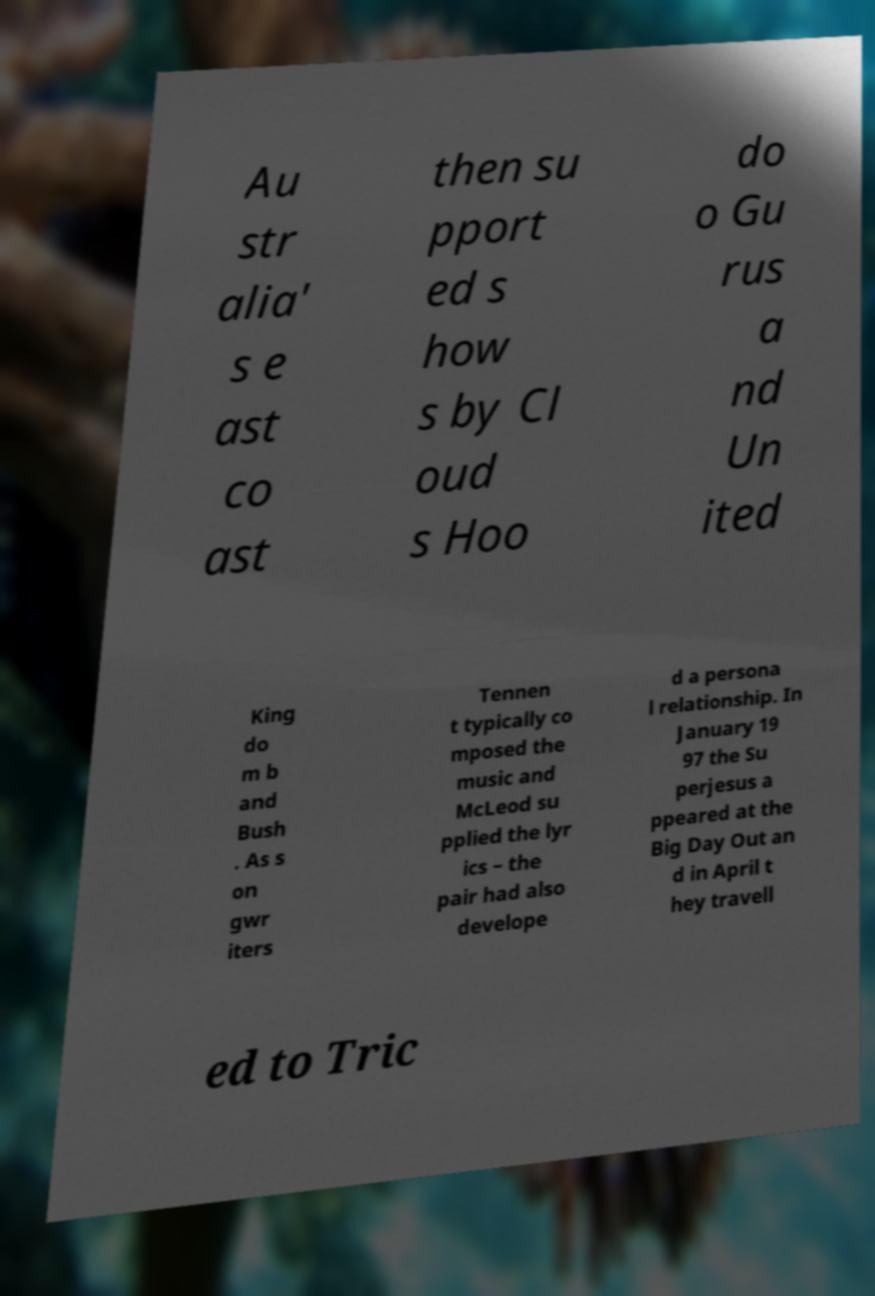Can you accurately transcribe the text from the provided image for me? Au str alia' s e ast co ast then su pport ed s how s by Cl oud s Hoo do o Gu rus a nd Un ited King do m b and Bush . As s on gwr iters Tennen t typically co mposed the music and McLeod su pplied the lyr ics – the pair had also develope d a persona l relationship. In January 19 97 the Su perjesus a ppeared at the Big Day Out an d in April t hey travell ed to Tric 